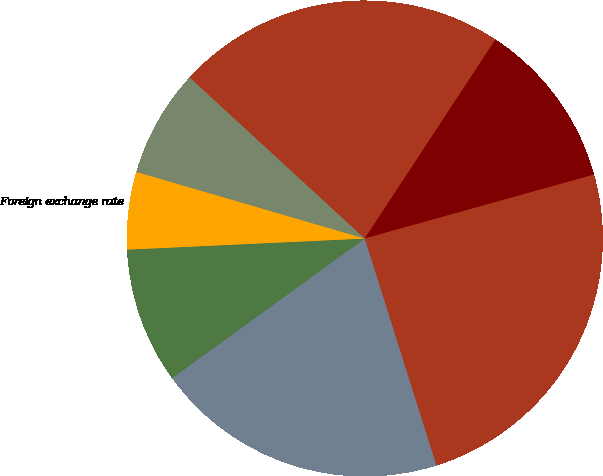Convert chart. <chart><loc_0><loc_0><loc_500><loc_500><pie_chart><fcel>Interest rate and credit<fcel>Equity price<fcel>Foreign exchange rate<fcel>Commodity price<fcel>Primary Risk Categories<fcel>Credit Portfolio<fcel>Total Trading VaR<nl><fcel>19.89%<fcel>9.24%<fcel>5.26%<fcel>7.32%<fcel>22.41%<fcel>11.43%<fcel>24.46%<nl></chart> 